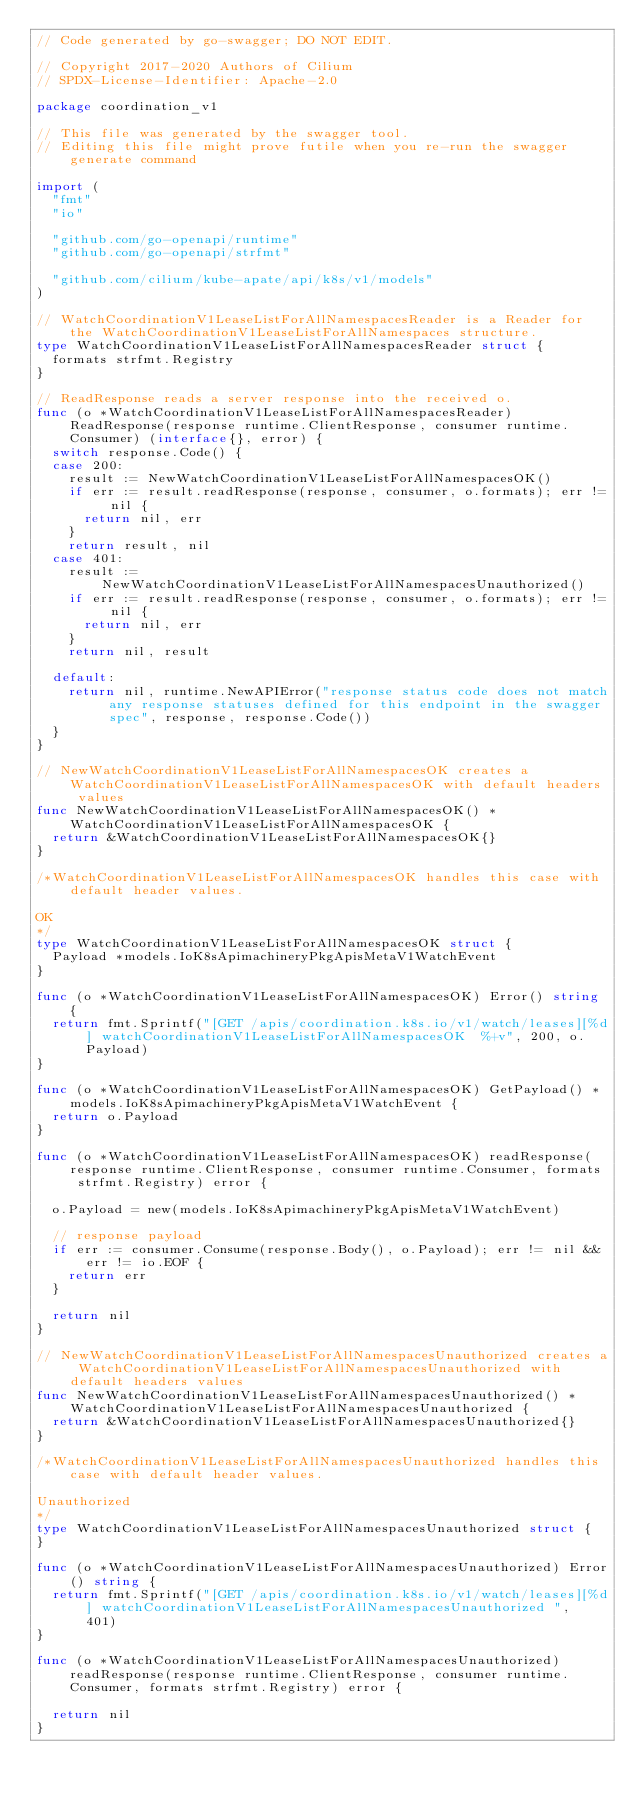<code> <loc_0><loc_0><loc_500><loc_500><_Go_>// Code generated by go-swagger; DO NOT EDIT.

// Copyright 2017-2020 Authors of Cilium
// SPDX-License-Identifier: Apache-2.0

package coordination_v1

// This file was generated by the swagger tool.
// Editing this file might prove futile when you re-run the swagger generate command

import (
	"fmt"
	"io"

	"github.com/go-openapi/runtime"
	"github.com/go-openapi/strfmt"

	"github.com/cilium/kube-apate/api/k8s/v1/models"
)

// WatchCoordinationV1LeaseListForAllNamespacesReader is a Reader for the WatchCoordinationV1LeaseListForAllNamespaces structure.
type WatchCoordinationV1LeaseListForAllNamespacesReader struct {
	formats strfmt.Registry
}

// ReadResponse reads a server response into the received o.
func (o *WatchCoordinationV1LeaseListForAllNamespacesReader) ReadResponse(response runtime.ClientResponse, consumer runtime.Consumer) (interface{}, error) {
	switch response.Code() {
	case 200:
		result := NewWatchCoordinationV1LeaseListForAllNamespacesOK()
		if err := result.readResponse(response, consumer, o.formats); err != nil {
			return nil, err
		}
		return result, nil
	case 401:
		result := NewWatchCoordinationV1LeaseListForAllNamespacesUnauthorized()
		if err := result.readResponse(response, consumer, o.formats); err != nil {
			return nil, err
		}
		return nil, result

	default:
		return nil, runtime.NewAPIError("response status code does not match any response statuses defined for this endpoint in the swagger spec", response, response.Code())
	}
}

// NewWatchCoordinationV1LeaseListForAllNamespacesOK creates a WatchCoordinationV1LeaseListForAllNamespacesOK with default headers values
func NewWatchCoordinationV1LeaseListForAllNamespacesOK() *WatchCoordinationV1LeaseListForAllNamespacesOK {
	return &WatchCoordinationV1LeaseListForAllNamespacesOK{}
}

/*WatchCoordinationV1LeaseListForAllNamespacesOK handles this case with default header values.

OK
*/
type WatchCoordinationV1LeaseListForAllNamespacesOK struct {
	Payload *models.IoK8sApimachineryPkgApisMetaV1WatchEvent
}

func (o *WatchCoordinationV1LeaseListForAllNamespacesOK) Error() string {
	return fmt.Sprintf("[GET /apis/coordination.k8s.io/v1/watch/leases][%d] watchCoordinationV1LeaseListForAllNamespacesOK  %+v", 200, o.Payload)
}

func (o *WatchCoordinationV1LeaseListForAllNamespacesOK) GetPayload() *models.IoK8sApimachineryPkgApisMetaV1WatchEvent {
	return o.Payload
}

func (o *WatchCoordinationV1LeaseListForAllNamespacesOK) readResponse(response runtime.ClientResponse, consumer runtime.Consumer, formats strfmt.Registry) error {

	o.Payload = new(models.IoK8sApimachineryPkgApisMetaV1WatchEvent)

	// response payload
	if err := consumer.Consume(response.Body(), o.Payload); err != nil && err != io.EOF {
		return err
	}

	return nil
}

// NewWatchCoordinationV1LeaseListForAllNamespacesUnauthorized creates a WatchCoordinationV1LeaseListForAllNamespacesUnauthorized with default headers values
func NewWatchCoordinationV1LeaseListForAllNamespacesUnauthorized() *WatchCoordinationV1LeaseListForAllNamespacesUnauthorized {
	return &WatchCoordinationV1LeaseListForAllNamespacesUnauthorized{}
}

/*WatchCoordinationV1LeaseListForAllNamespacesUnauthorized handles this case with default header values.

Unauthorized
*/
type WatchCoordinationV1LeaseListForAllNamespacesUnauthorized struct {
}

func (o *WatchCoordinationV1LeaseListForAllNamespacesUnauthorized) Error() string {
	return fmt.Sprintf("[GET /apis/coordination.k8s.io/v1/watch/leases][%d] watchCoordinationV1LeaseListForAllNamespacesUnauthorized ", 401)
}

func (o *WatchCoordinationV1LeaseListForAllNamespacesUnauthorized) readResponse(response runtime.ClientResponse, consumer runtime.Consumer, formats strfmt.Registry) error {

	return nil
}
</code> 